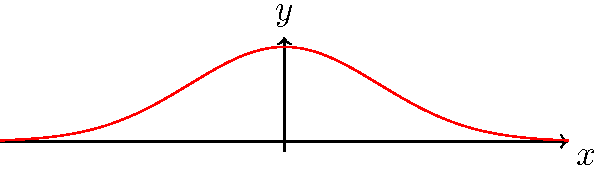As the CEO of a pharmaceutical company, you're analyzing the patient response rates to a new drug. The original bell curve (in blue) represents the current distribution. You want to reflect this curve across the y-axis to compare it with a theoretical model. What transformation should be applied to the function $f(x) = e^{-\frac{x^2}{2}}$ to achieve this reflection (shown in red)? To reflect a function across the y-axis, we need to follow these steps:

1) The general form of reflection across the y-axis is to replace x with -x in the original function.

2) Our original function is $f(x) = e^{-\frac{x^2}{2}}$

3) To reflect it, we replace x with -x:
   $f(-x) = e^{-\frac{(-x)^2}{2}}$

4) Simplify the exponent:
   $f(-x) = e^{-\frac{x^2}{2}}$

5) We can see that $f(-x) = f(x)$ for this particular function, which means it's symmetric about the y-axis.

6) Therefore, the transformation to reflect $f(x) = e^{-\frac{x^2}{2}}$ across the y-axis is simply $f(-x)$.
Answer: $f(-x)$ 